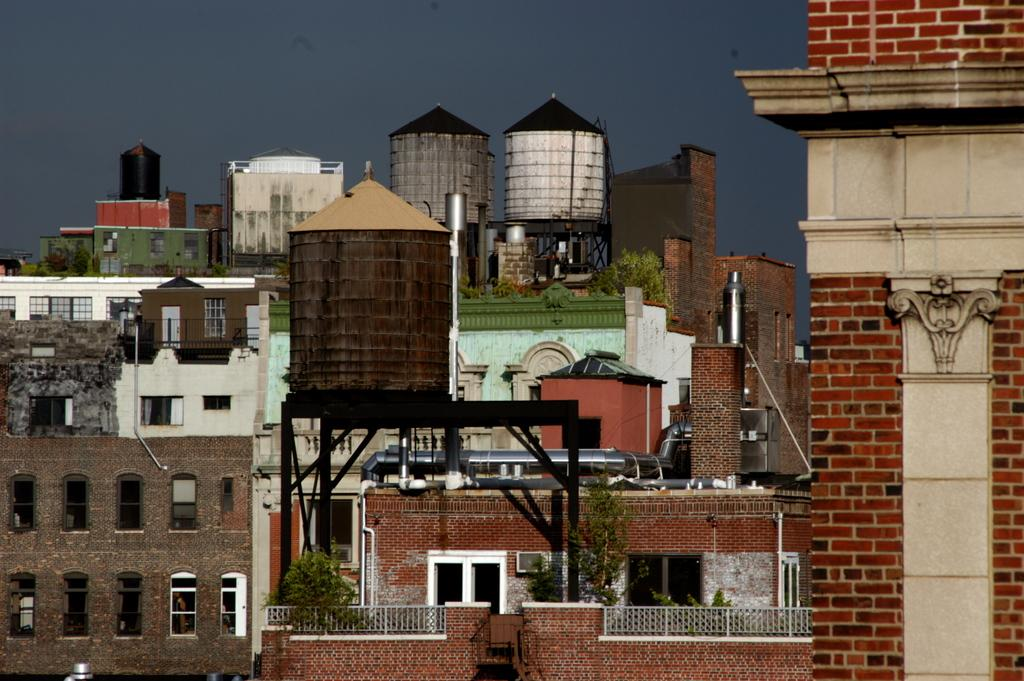What type of structures can be seen in the image? There are buildings in the image. Can you identify any specific features of these structures? Yes, there are overhead tanks visible in the image. What type of lip can be seen on the fowl in the image? There are no fowl or lips present in the image; it only features buildings and overhead tanks. 